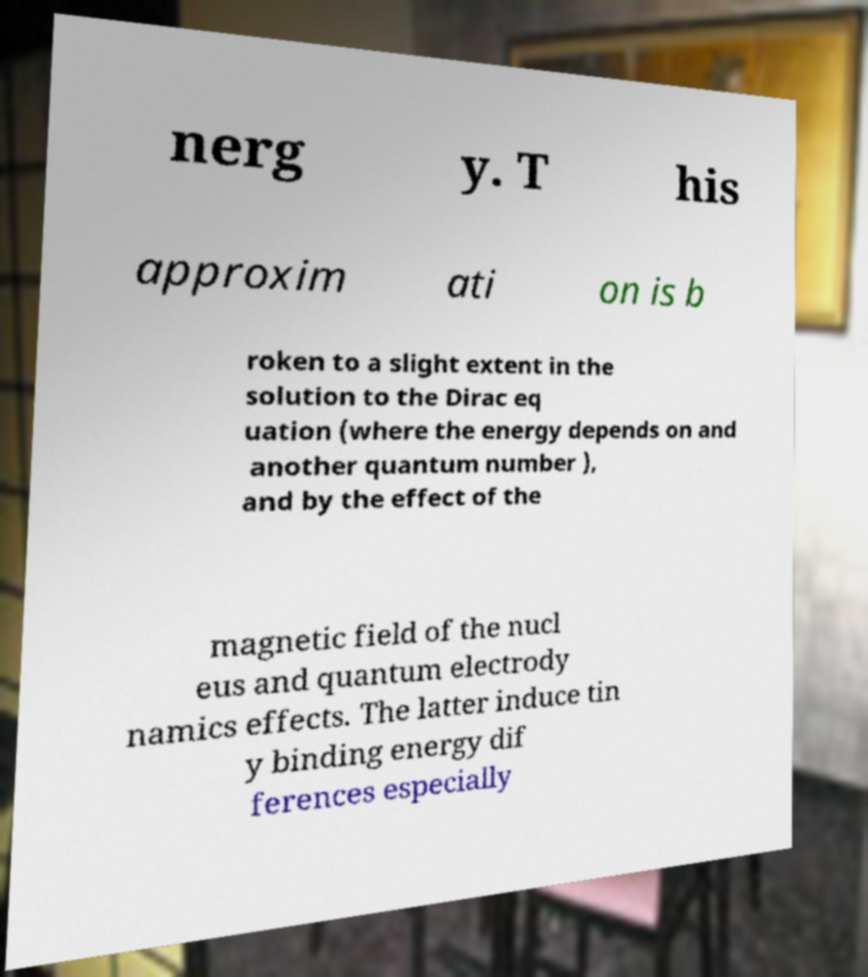Please read and relay the text visible in this image. What does it say? nerg y. T his approxim ati on is b roken to a slight extent in the solution to the Dirac eq uation (where the energy depends on and another quantum number ), and by the effect of the magnetic field of the nucl eus and quantum electrody namics effects. The latter induce tin y binding energy dif ferences especially 